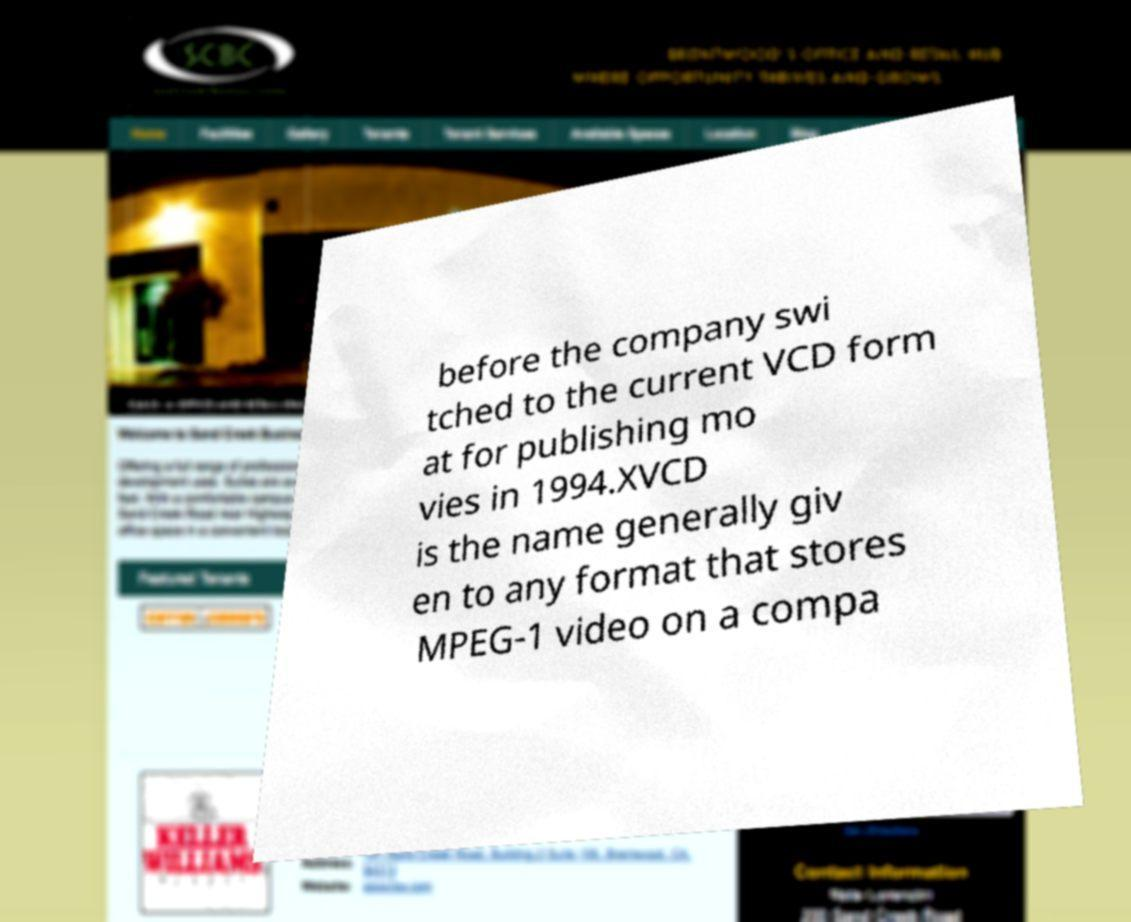I need the written content from this picture converted into text. Can you do that? before the company swi tched to the current VCD form at for publishing mo vies in 1994.XVCD is the name generally giv en to any format that stores MPEG-1 video on a compa 